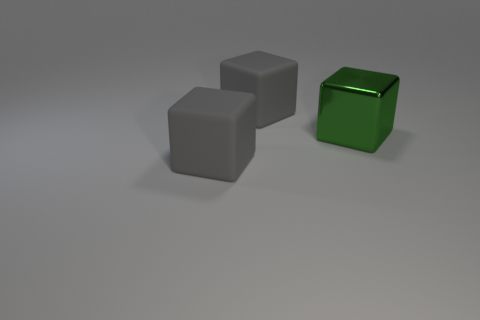Is the color of the object in front of the green block the same as the matte object behind the big green cube?
Your answer should be very brief. Yes. What material is the gray object right of the gray thing that is in front of the gray rubber thing that is behind the large green metal thing?
Offer a terse response. Rubber. How many objects have the same color as the metallic cube?
Make the answer very short. 0. Are there more large rubber cubes in front of the big green shiny thing than red matte balls?
Your answer should be very brief. Yes. There is a matte object that is in front of the rubber block behind the metal block; what color is it?
Offer a terse response. Gray. How many objects are large gray rubber cubes that are in front of the big green metal block or big rubber cubes that are in front of the green shiny object?
Offer a very short reply. 1. The large metallic object has what color?
Keep it short and to the point. Green. How many gray things are made of the same material as the large green thing?
Offer a terse response. 0. Is the number of large gray matte things greater than the number of large objects?
Ensure brevity in your answer.  No. What number of cubes are in front of the big thing behind the big metal block?
Keep it short and to the point. 2. 